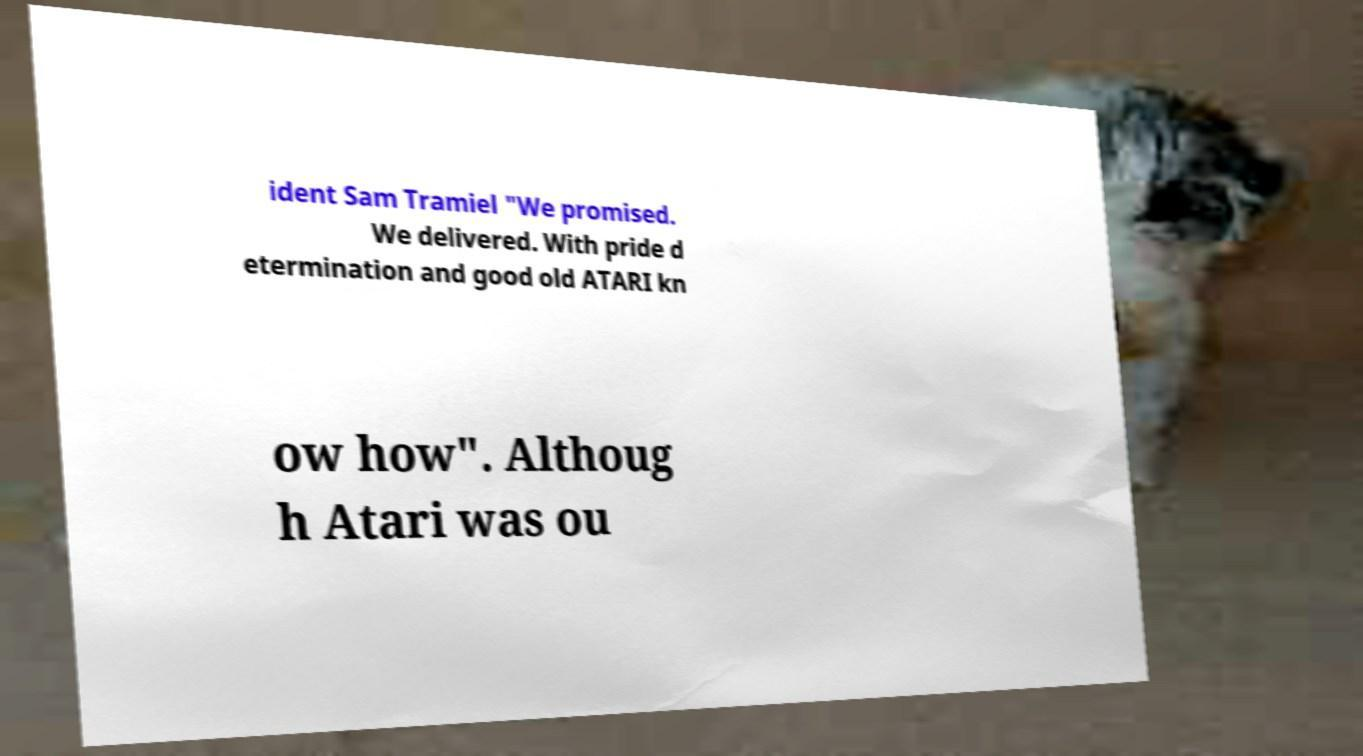Please read and relay the text visible in this image. What does it say? ident Sam Tramiel "We promised. We delivered. With pride d etermination and good old ATARI kn ow how". Althoug h Atari was ou 